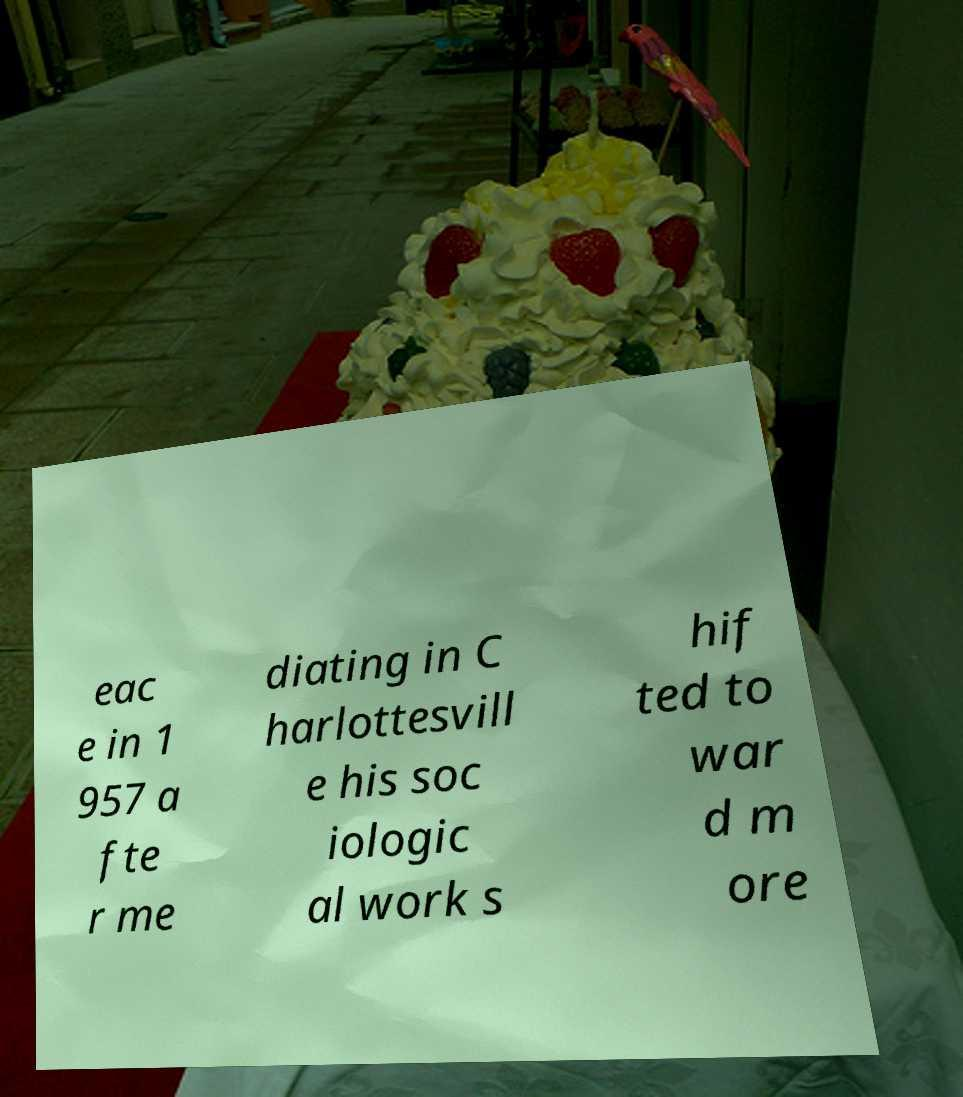I need the written content from this picture converted into text. Can you do that? eac e in 1 957 a fte r me diating in C harlottesvill e his soc iologic al work s hif ted to war d m ore 